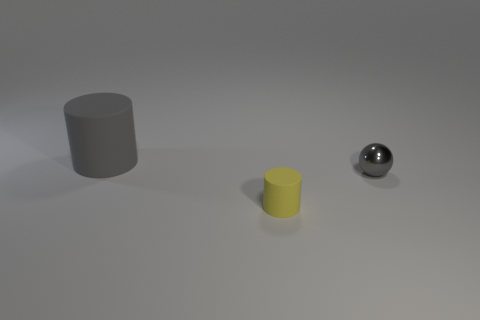Add 1 large purple rubber objects. How many objects exist? 4 Subtract all cylinders. How many objects are left? 1 Subtract all small gray shiny objects. Subtract all tiny rubber blocks. How many objects are left? 2 Add 2 large gray cylinders. How many large gray cylinders are left? 3 Add 2 big cyan balls. How many big cyan balls exist? 2 Subtract 1 gray balls. How many objects are left? 2 